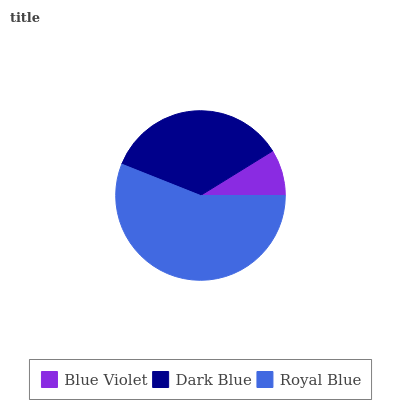Is Blue Violet the minimum?
Answer yes or no. Yes. Is Royal Blue the maximum?
Answer yes or no. Yes. Is Dark Blue the minimum?
Answer yes or no. No. Is Dark Blue the maximum?
Answer yes or no. No. Is Dark Blue greater than Blue Violet?
Answer yes or no. Yes. Is Blue Violet less than Dark Blue?
Answer yes or no. Yes. Is Blue Violet greater than Dark Blue?
Answer yes or no. No. Is Dark Blue less than Blue Violet?
Answer yes or no. No. Is Dark Blue the high median?
Answer yes or no. Yes. Is Dark Blue the low median?
Answer yes or no. Yes. Is Blue Violet the high median?
Answer yes or no. No. Is Blue Violet the low median?
Answer yes or no. No. 